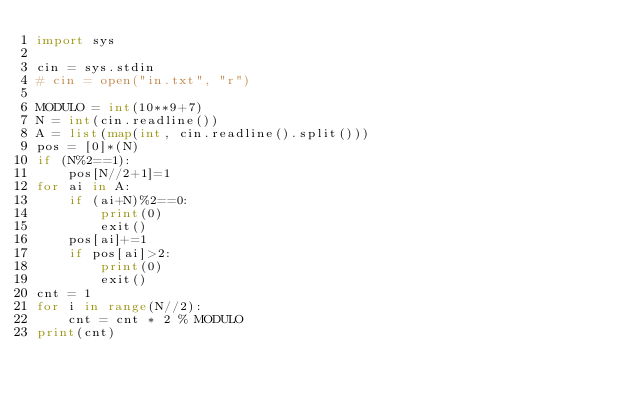Convert code to text. <code><loc_0><loc_0><loc_500><loc_500><_Python_>import sys

cin = sys.stdin
# cin = open("in.txt", "r")

MODULO = int(10**9+7)
N = int(cin.readline())
A = list(map(int, cin.readline().split()))
pos = [0]*(N)
if (N%2==1):
    pos[N//2+1]=1
for ai in A:
    if (ai+N)%2==0:
        print(0)
        exit()
    pos[ai]+=1
    if pos[ai]>2:
        print(0)
        exit()
cnt = 1
for i in range(N//2):
    cnt = cnt * 2 % MODULO
print(cnt)</code> 